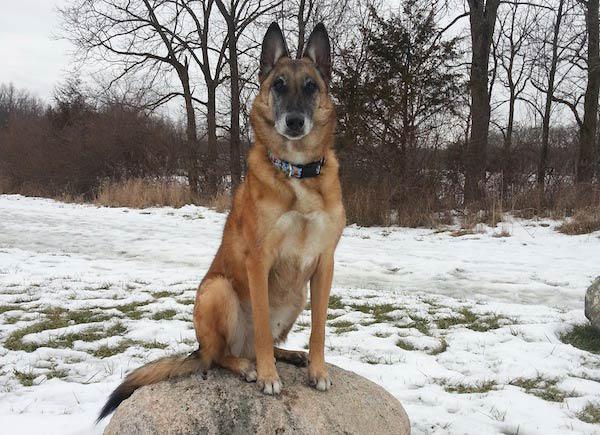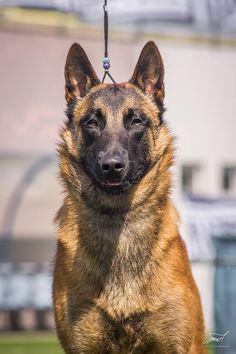The first image is the image on the left, the second image is the image on the right. For the images displayed, is the sentence "The left photo shows a dog on top of a rock." factually correct? Answer yes or no. Yes. The first image is the image on the left, the second image is the image on the right. Considering the images on both sides, is "There are two dogs shown." valid? Answer yes or no. Yes. 